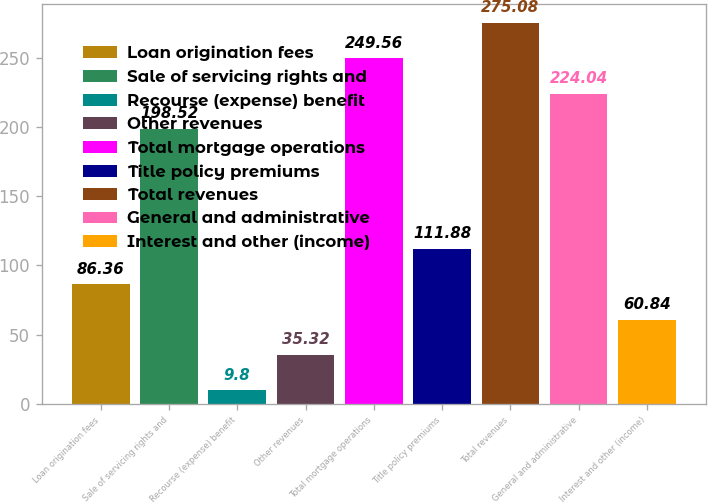Convert chart. <chart><loc_0><loc_0><loc_500><loc_500><bar_chart><fcel>Loan origination fees<fcel>Sale of servicing rights and<fcel>Recourse (expense) benefit<fcel>Other revenues<fcel>Total mortgage operations<fcel>Title policy premiums<fcel>Total revenues<fcel>General and administrative<fcel>Interest and other (income)<nl><fcel>86.36<fcel>198.52<fcel>9.8<fcel>35.32<fcel>249.56<fcel>111.88<fcel>275.08<fcel>224.04<fcel>60.84<nl></chart> 